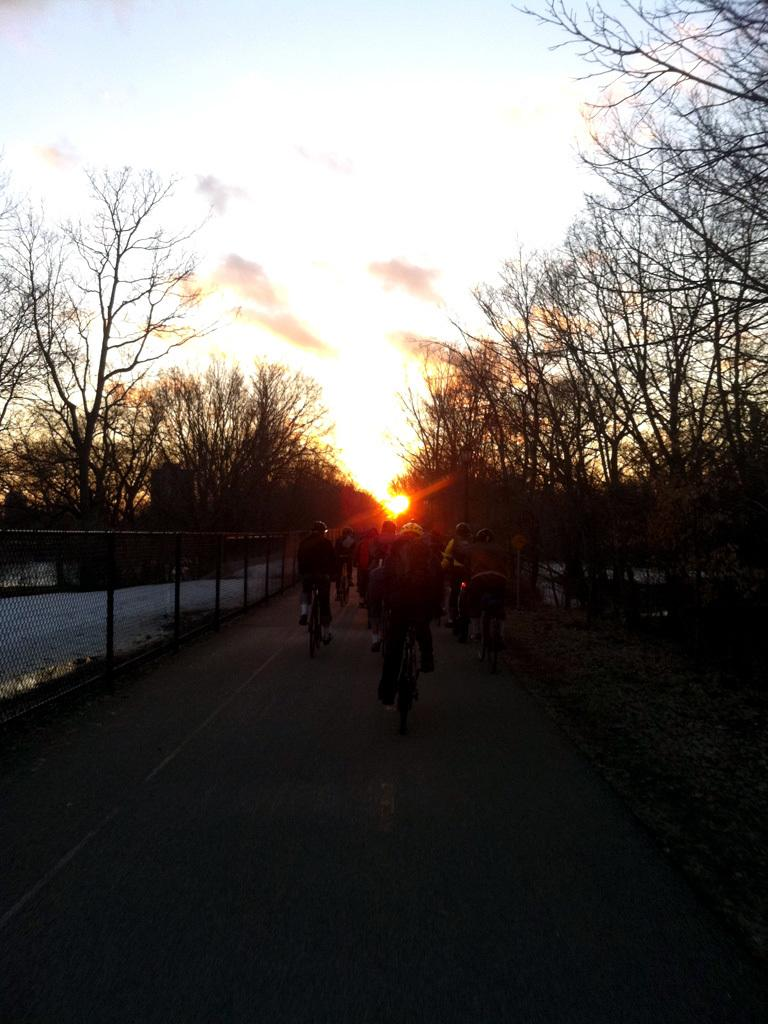What are the people in the image doing? The people in the image are riding bicycles on the road. What can be seen in the middle of the image? There are trees in the middle of the image. What is visible in the background of the image? The background of the image is the sky. What type of pie is being served on the coach in the image? There is no coach or pie present in the image; it features people riding bicycles on the road with trees and the sky in the background. 